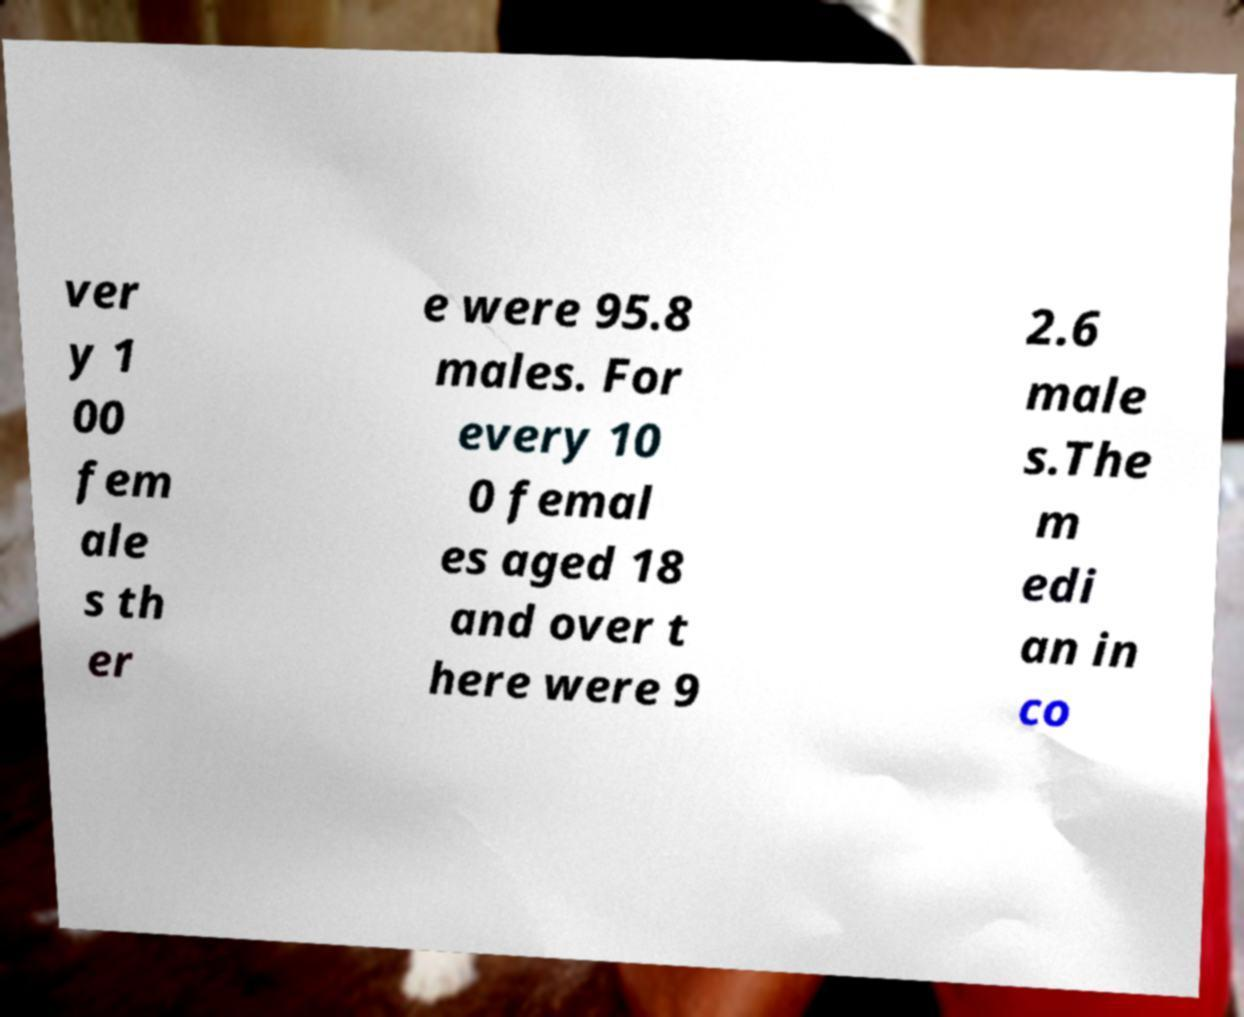Could you assist in decoding the text presented in this image and type it out clearly? ver y 1 00 fem ale s th er e were 95.8 males. For every 10 0 femal es aged 18 and over t here were 9 2.6 male s.The m edi an in co 